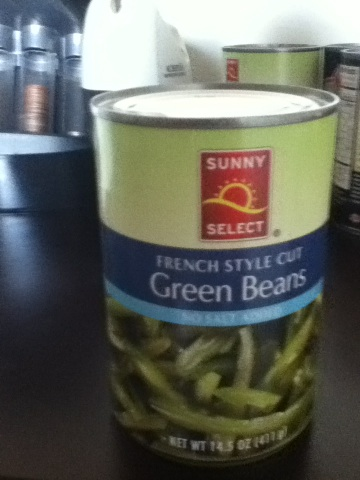What is this? from Vizwiz The image displays a can of 'Sunny Select French Style Cut Green Beans'. The can is predominantly green and blue with 'Sunny Select' as the brand prominently featured at the top. These green beans are a common canned vegetable, convenient for quick cooking and long-term storage. 